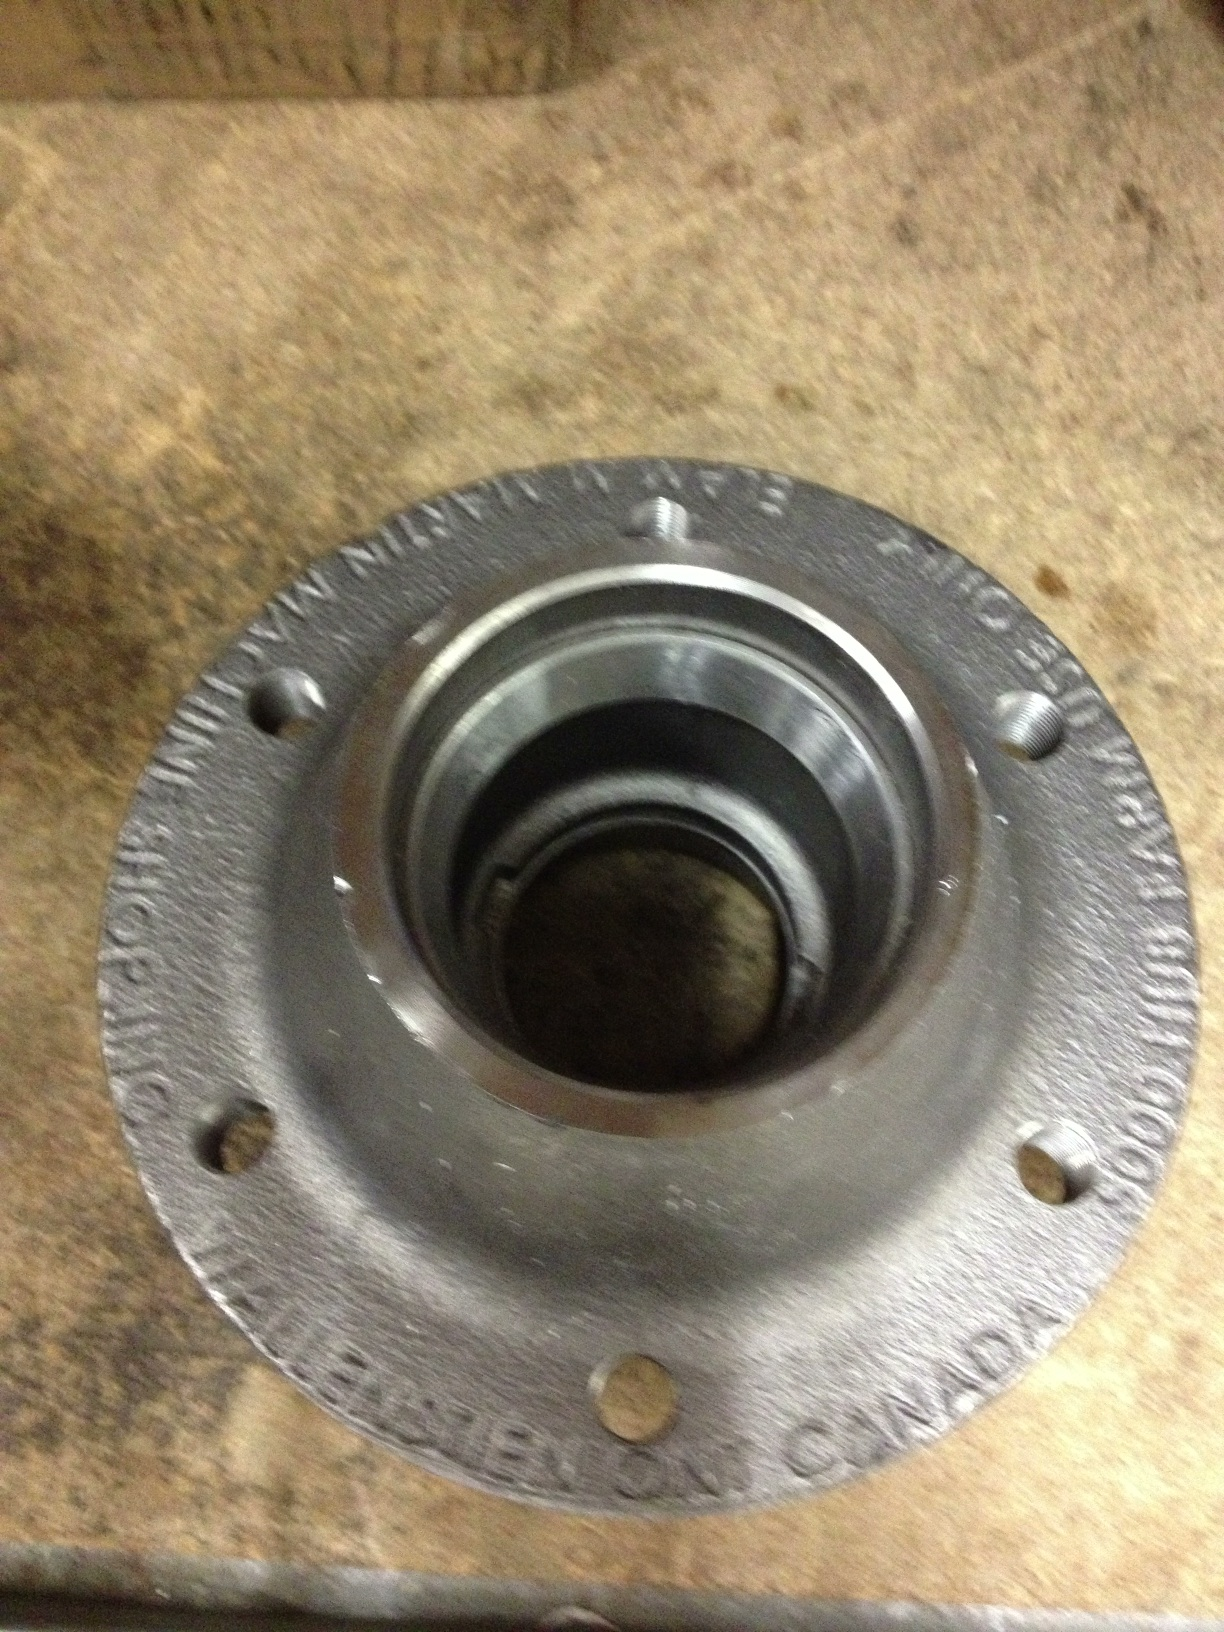Is this wheel hub used in any specific types of vehicles? This type of wheel hub is commonly found in a variety of vehicles, including cars, trucks, and trailers. Its design indicates it could be used in heavy-duty applications, suggesting it might belong to larger vehicles or industrial equipment. The robust construction is necessary to handle heavy loads and rough terrain, ensuring reliability and durability in demanding environments. Can you explain how to replace a wheel hub? To replace a wheel hub, follow these general steps:

1. **Preparation:** Ensure the vehicle is on a flat surface, engage the parking brake, and use wheel chocks for safety. Loosen the lug nuts on the wheel.
2. **Lift the Vehicle:** Use a jack to lift the vehicle and secure it with jack stands.
3. **Remove the Wheel:** Fully remove the lug nuts and take off the wheel.
4. **Remove the Brake Components:** Detach the brake caliper and rotor to access the hub assembly. Support the caliper to avoid strain on the brake line.
5. **Disconnect the Hub:** Remove any clips or bolts holding the hub assembly in place. You may need to disconnect sensors, such as ABS sensors.
6. **Install the New Hub:** Position the new hub assembly, securing it with bolts and reconnecting sensors.
7. **Reassemble the Brake Components:** Reattach the brake rotor and caliper.
8. **Replace the Wheel:** Put the wheel back on, hand-tighten the lug nuts.
9. **Lower the Vehicle:** Carefully lower the vehicle and fully tighten the lug nuts in a crisscross pattern.
10. **Test Drive:** Check for proper installation by test driving and listening for unusual noises.

Note: These steps are general guidelines. Always refer to the vehicle’s service manual for specific instructions. 